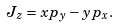Convert formula to latex. <formula><loc_0><loc_0><loc_500><loc_500>J _ { z } = x p _ { y } - y p _ { x } .</formula> 